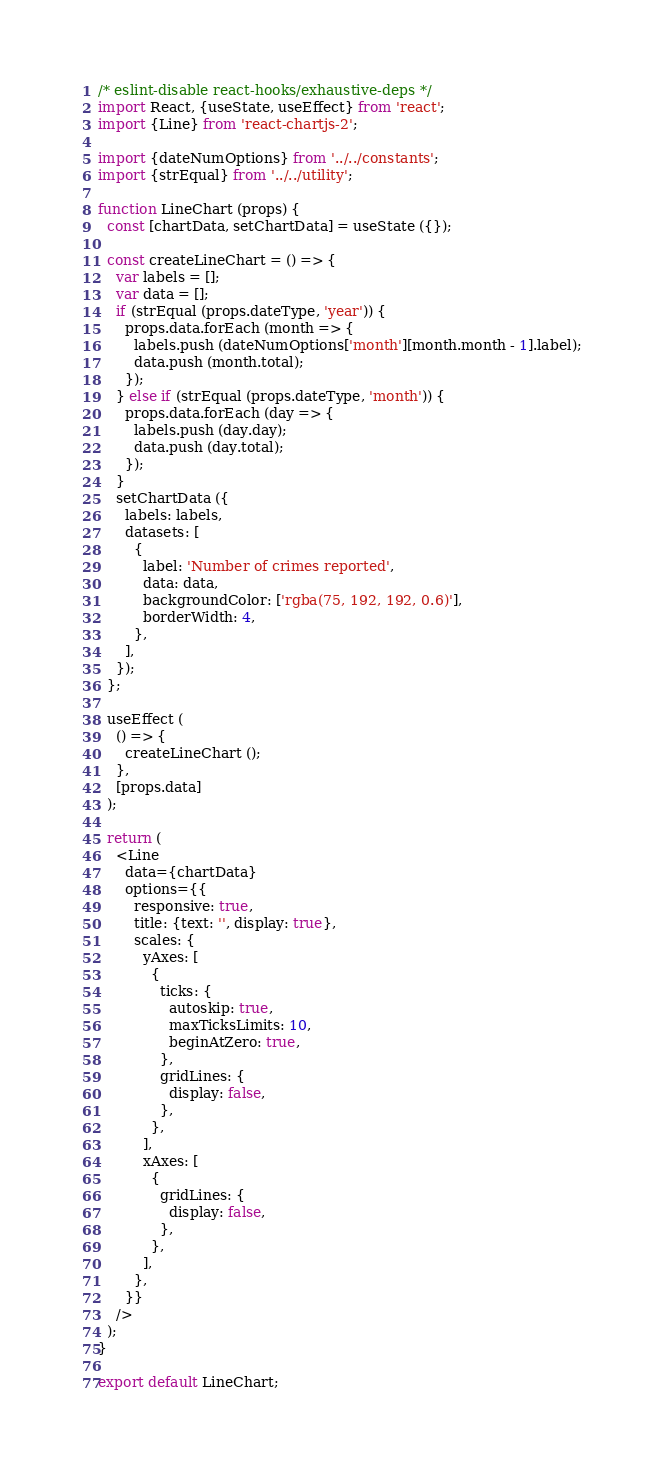Convert code to text. <code><loc_0><loc_0><loc_500><loc_500><_JavaScript_>/* eslint-disable react-hooks/exhaustive-deps */
import React, {useState, useEffect} from 'react';
import {Line} from 'react-chartjs-2';

import {dateNumOptions} from '../../constants';
import {strEqual} from '../../utility';

function LineChart (props) {
  const [chartData, setChartData] = useState ({});

  const createLineChart = () => {
    var labels = [];
    var data = [];
    if (strEqual (props.dateType, 'year')) {
      props.data.forEach (month => {
        labels.push (dateNumOptions['month'][month.month - 1].label);
        data.push (month.total);
      });
    } else if (strEqual (props.dateType, 'month')) {
      props.data.forEach (day => {
        labels.push (day.day);
        data.push (day.total);
      });
    }
    setChartData ({
      labels: labels,
      datasets: [
        {
          label: 'Number of crimes reported',
          data: data,
          backgroundColor: ['rgba(75, 192, 192, 0.6)'],
          borderWidth: 4,
        },
      ],
    });
  };

  useEffect (
    () => {
      createLineChart ();
    },
    [props.data]
  );

  return (
    <Line
      data={chartData}
      options={{
        responsive: true,
        title: {text: '', display: true},
        scales: {
          yAxes: [
            {
              ticks: {
                autoskip: true,
                maxTicksLimits: 10,
                beginAtZero: true,
              },
              gridLines: {
                display: false,
              },
            },
          ],
          xAxes: [
            {
              gridLines: {
                display: false,
              },
            },
          ],
        },
      }}
    />
  );
}

export default LineChart;
</code> 